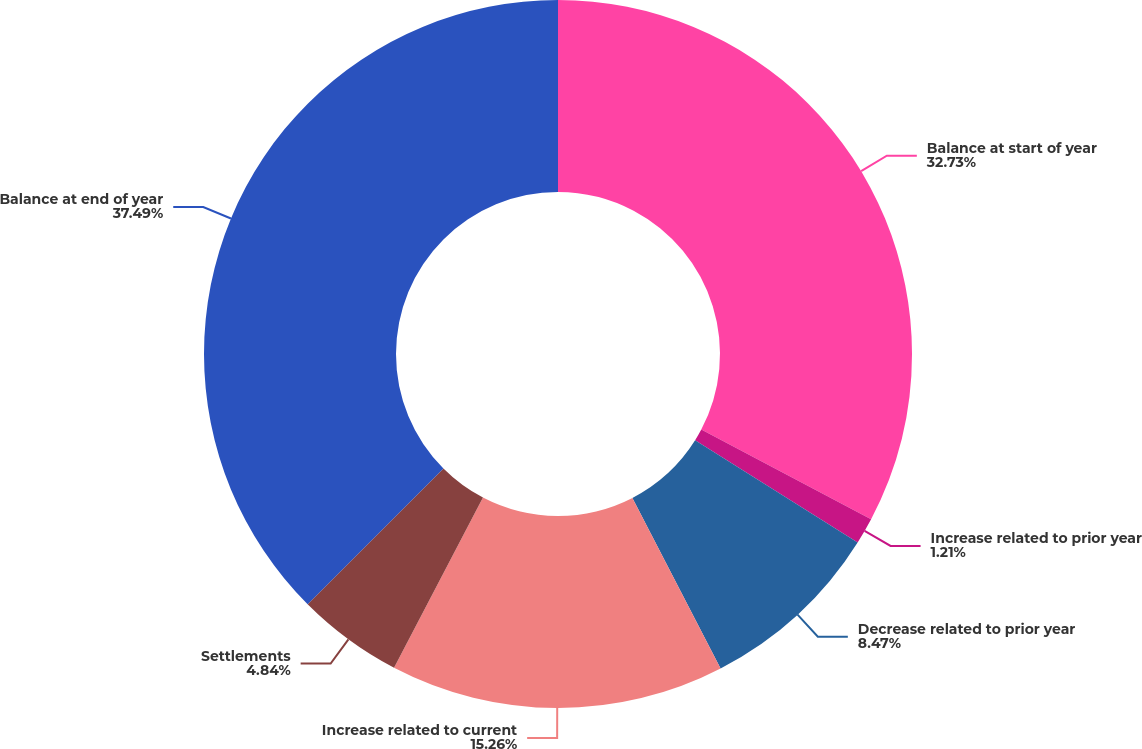Convert chart. <chart><loc_0><loc_0><loc_500><loc_500><pie_chart><fcel>Balance at start of year<fcel>Increase related to prior year<fcel>Decrease related to prior year<fcel>Increase related to current<fcel>Settlements<fcel>Balance at end of year<nl><fcel>32.73%<fcel>1.21%<fcel>8.47%<fcel>15.26%<fcel>4.84%<fcel>37.5%<nl></chart> 